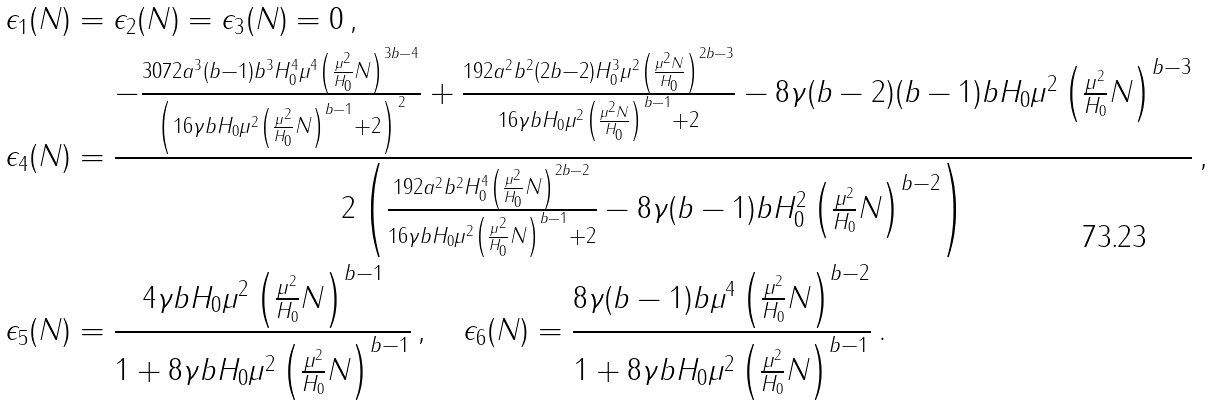Convert formula to latex. <formula><loc_0><loc_0><loc_500><loc_500>\epsilon _ { 1 } ( N ) & = \epsilon _ { 2 } ( N ) = \epsilon _ { 3 } ( N ) = 0 \, , \\ \epsilon _ { 4 } ( N ) & = \frac { - \frac { 3 0 7 2 a ^ { 3 } ( b - 1 ) b ^ { 3 } H _ { 0 } ^ { 4 } \mu ^ { 4 } \left ( \frac { \mu ^ { 2 } } { H _ { 0 } } N \right ) ^ { 3 b - 4 } } { \left ( 1 6 \gamma b H _ { 0 } \mu ^ { 2 } \left ( \frac { \mu ^ { 2 } } { H _ { 0 } } N \right ) ^ { b - 1 } + 2 \right ) ^ { 2 } } + \frac { 1 9 2 a ^ { 2 } b ^ { 2 } ( 2 b - 2 ) H _ { 0 } ^ { 3 } \mu ^ { 2 } \left ( \frac { \mu ^ { 2 } N } { H _ { 0 } } \right ) ^ { 2 b - 3 } } { 1 6 \gamma b H _ { 0 } \mu ^ { 2 } \left ( \frac { \mu ^ { 2 } N } { H _ { 0 } } \right ) ^ { b - 1 } + 2 } - 8 \gamma ( b - 2 ) ( b - 1 ) b H _ { 0 } \mu ^ { 2 } \left ( \frac { \mu ^ { 2 } } { H _ { 0 } } N \right ) ^ { b - 3 } } { 2 \left ( \frac { 1 9 2 a ^ { 2 } b ^ { 2 } H _ { 0 } ^ { 4 } \left ( \frac { \mu ^ { 2 } } { H _ { 0 } } N \right ) ^ { 2 b - 2 } } { 1 6 \gamma b H _ { 0 } \mu ^ { 2 } \left ( \frac { \mu ^ { 2 } } { H _ { 0 } } N \right ) ^ { b - 1 } + 2 } - 8 \gamma ( b - 1 ) b H _ { 0 } ^ { 2 } \left ( \frac { \mu ^ { 2 } } { H _ { 0 } } N \right ) ^ { b - 2 } \right ) } \, , \\ \epsilon _ { 5 } ( N ) & = \frac { 4 \gamma b H _ { 0 } \mu ^ { 2 } \left ( \frac { \mu ^ { 2 } } { H _ { 0 } } N \right ) ^ { b - 1 } } { 1 + 8 \gamma b H _ { 0 } \mu ^ { 2 } \left ( \frac { \mu ^ { 2 } } { H _ { 0 } } N \right ) ^ { b - 1 } } \, , \quad \epsilon _ { 6 } ( N ) = \frac { 8 \gamma ( b - 1 ) b \mu ^ { 4 } \left ( \frac { \mu ^ { 2 } } { H _ { 0 } } N \right ) ^ { b - 2 } } { 1 + 8 \gamma b H _ { 0 } \mu ^ { 2 } \left ( \frac { \mu ^ { 2 } } { H _ { 0 } } N \right ) ^ { b - 1 } } \, .</formula> 